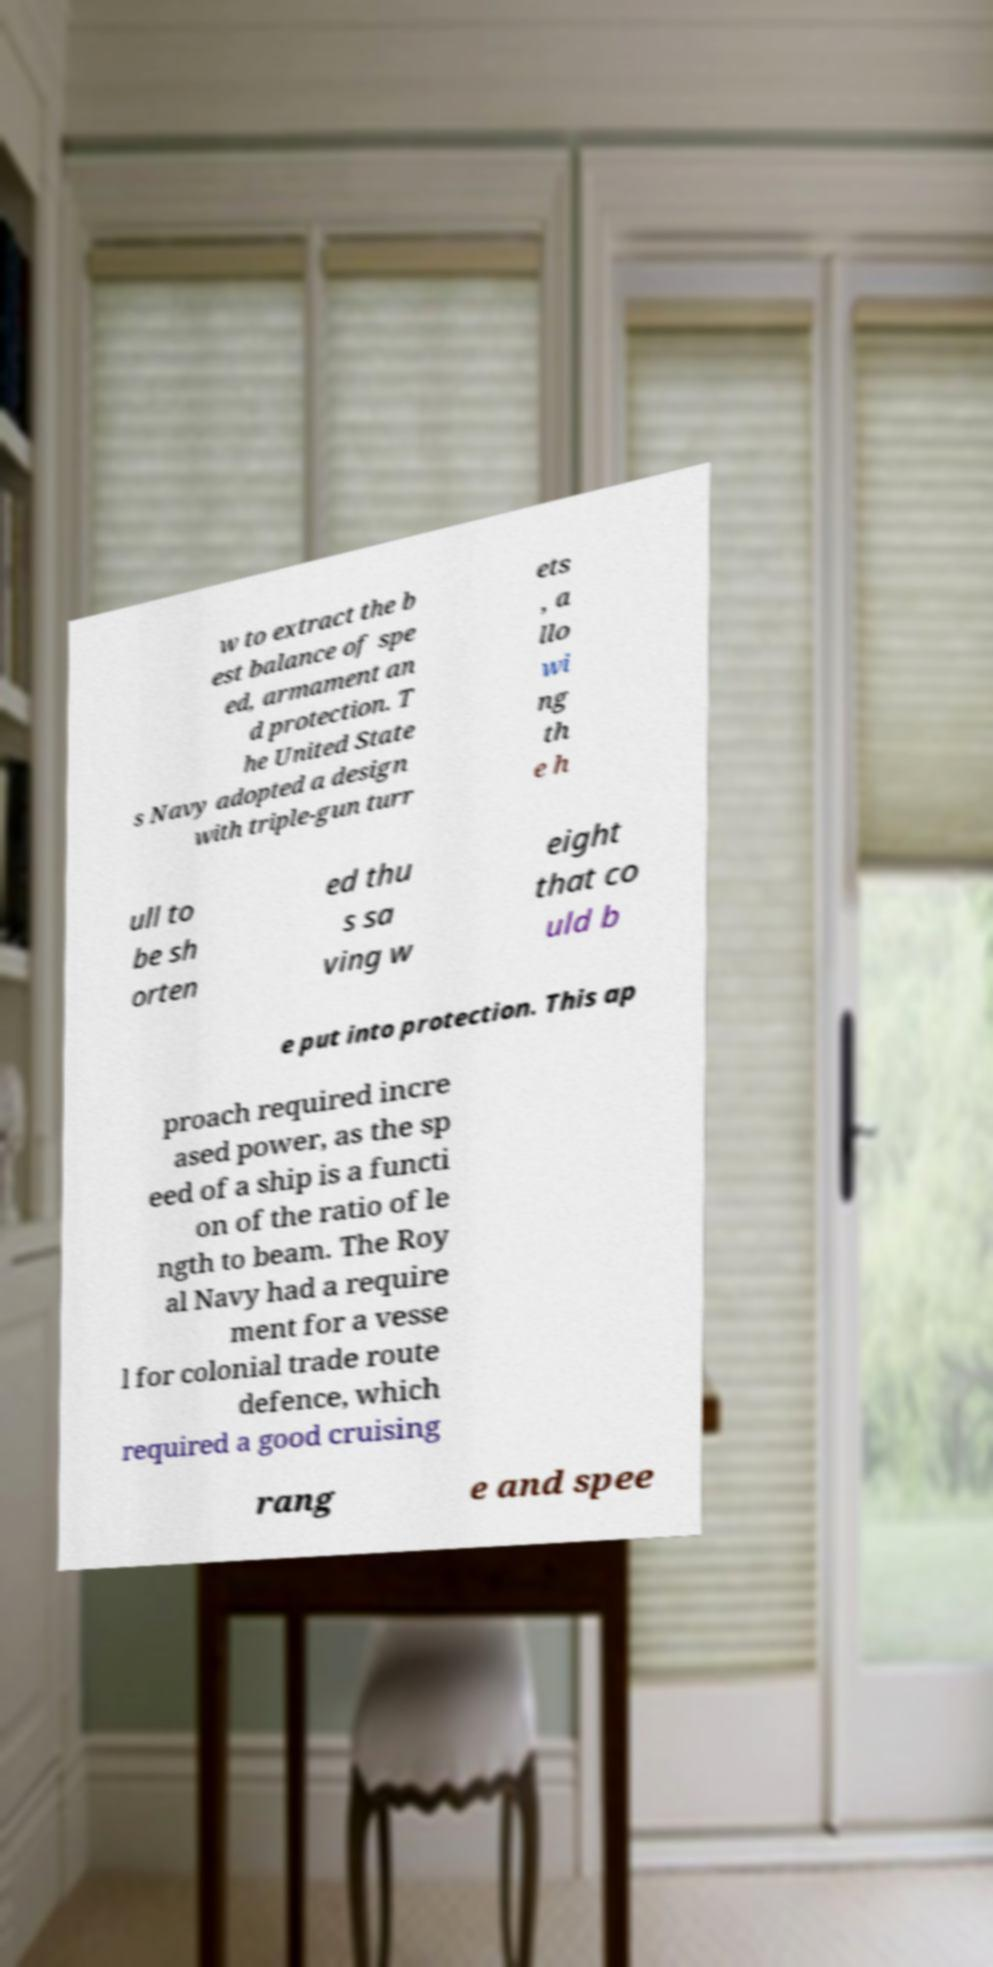Could you extract and type out the text from this image? w to extract the b est balance of spe ed, armament an d protection. T he United State s Navy adopted a design with triple-gun turr ets , a llo wi ng th e h ull to be sh orten ed thu s sa ving w eight that co uld b e put into protection. This ap proach required incre ased power, as the sp eed of a ship is a functi on of the ratio of le ngth to beam. The Roy al Navy had a require ment for a vesse l for colonial trade route defence, which required a good cruising rang e and spee 